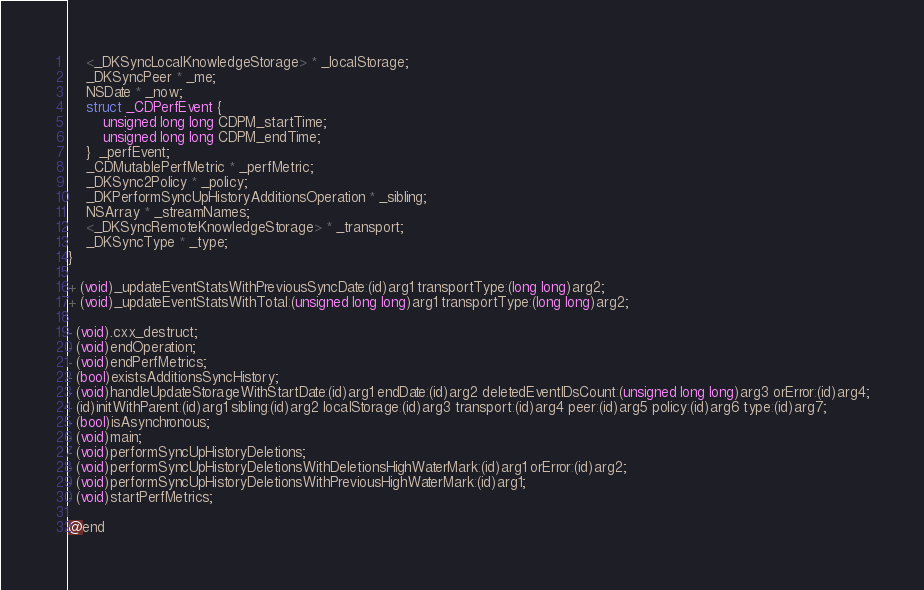Convert code to text. <code><loc_0><loc_0><loc_500><loc_500><_C_>    <_DKSyncLocalKnowledgeStorage> * _localStorage;
    _DKSyncPeer * _me;
    NSDate * _now;
    struct _CDPerfEvent { 
        unsigned long long CDPM_startTime; 
        unsigned long long CDPM_endTime; 
    }  _perfEvent;
    _CDMutablePerfMetric * _perfMetric;
    _DKSync2Policy * _policy;
    _DKPerformSyncUpHistoryAdditionsOperation * _sibling;
    NSArray * _streamNames;
    <_DKSyncRemoteKnowledgeStorage> * _transport;
    _DKSyncType * _type;
}

+ (void)_updateEventStatsWithPreviousSyncDate:(id)arg1 transportType:(long long)arg2;
+ (void)_updateEventStatsWithTotal:(unsigned long long)arg1 transportType:(long long)arg2;

- (void).cxx_destruct;
- (void)endOperation;
- (void)endPerfMetrics;
- (bool)existsAdditionsSyncHistory;
- (void)handleUpdateStorageWithStartDate:(id)arg1 endDate:(id)arg2 deletedEventIDsCount:(unsigned long long)arg3 orError:(id)arg4;
- (id)initWithParent:(id)arg1 sibling:(id)arg2 localStorage:(id)arg3 transport:(id)arg4 peer:(id)arg5 policy:(id)arg6 type:(id)arg7;
- (bool)isAsynchronous;
- (void)main;
- (void)performSyncUpHistoryDeletions;
- (void)performSyncUpHistoryDeletionsWithDeletionsHighWaterMark:(id)arg1 orError:(id)arg2;
- (void)performSyncUpHistoryDeletionsWithPreviousHighWaterMark:(id)arg1;
- (void)startPerfMetrics;

@end
</code> 